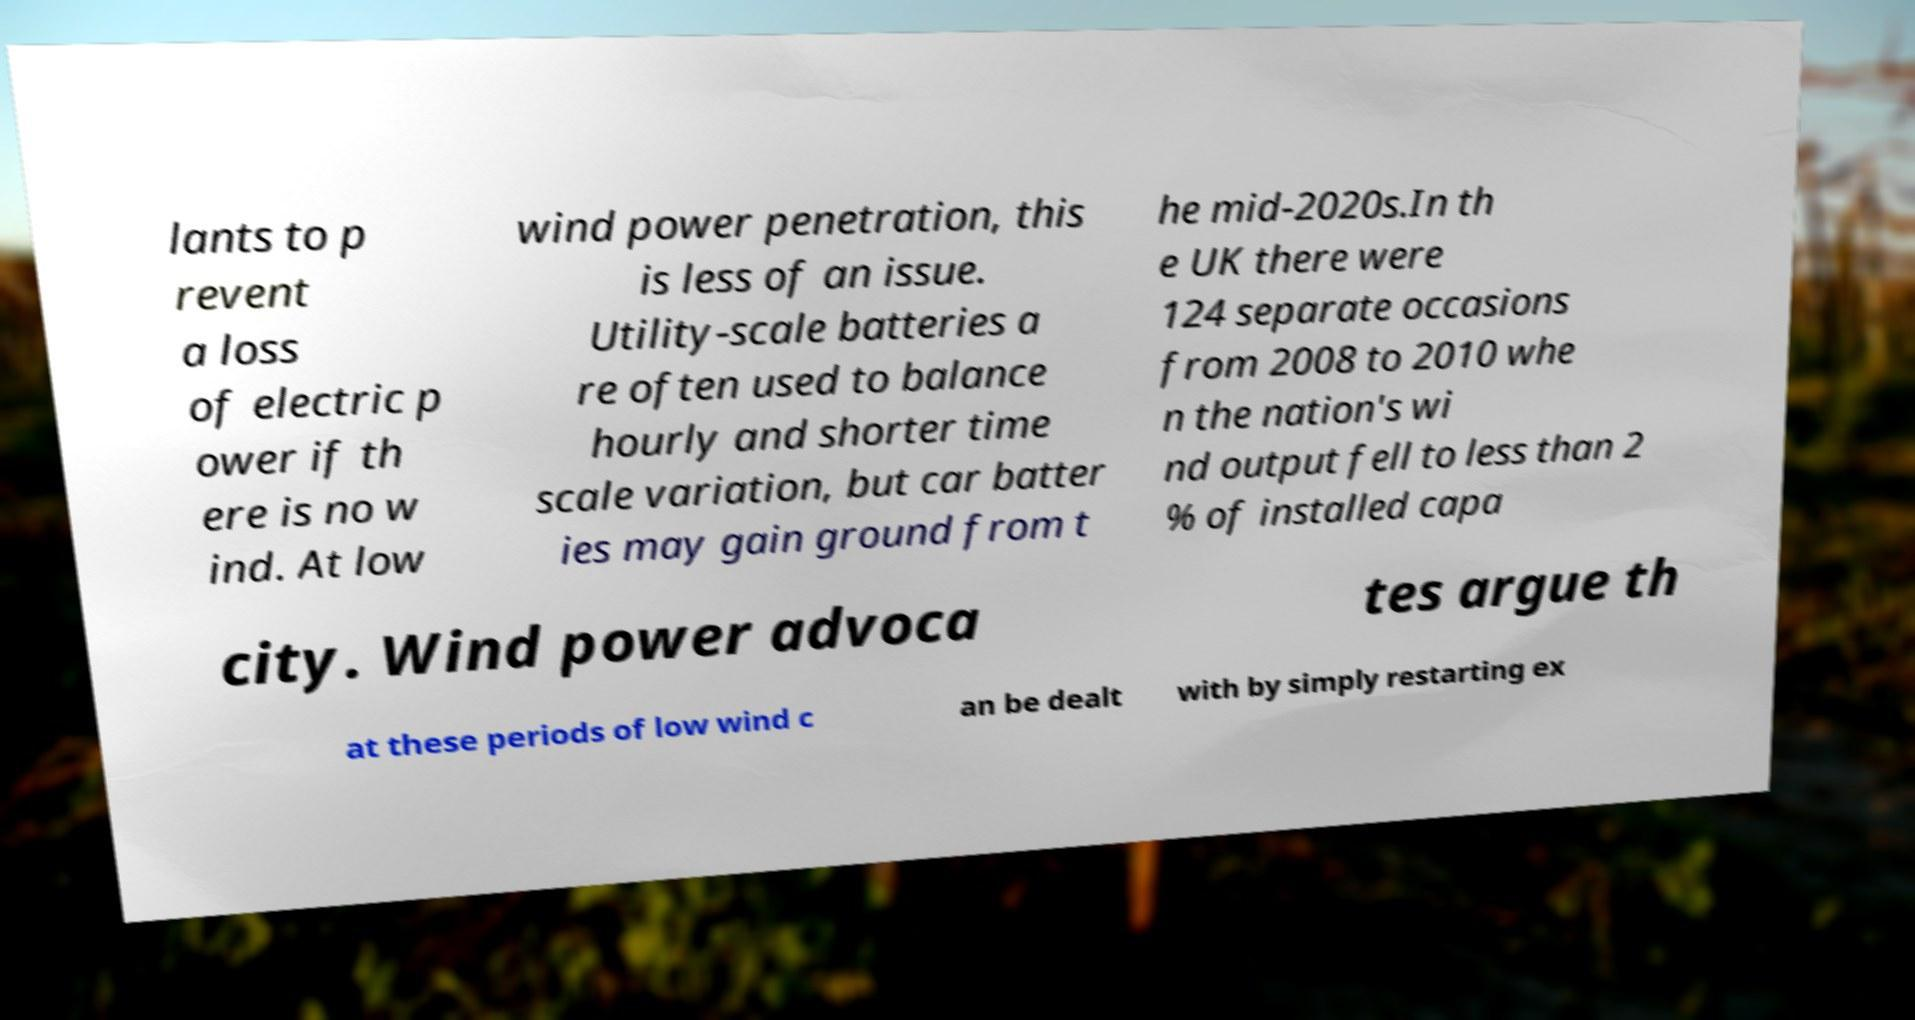Can you read and provide the text displayed in the image?This photo seems to have some interesting text. Can you extract and type it out for me? lants to p revent a loss of electric p ower if th ere is no w ind. At low wind power penetration, this is less of an issue. Utility-scale batteries a re often used to balance hourly and shorter time scale variation, but car batter ies may gain ground from t he mid-2020s.In th e UK there were 124 separate occasions from 2008 to 2010 whe n the nation's wi nd output fell to less than 2 % of installed capa city. Wind power advoca tes argue th at these periods of low wind c an be dealt with by simply restarting ex 